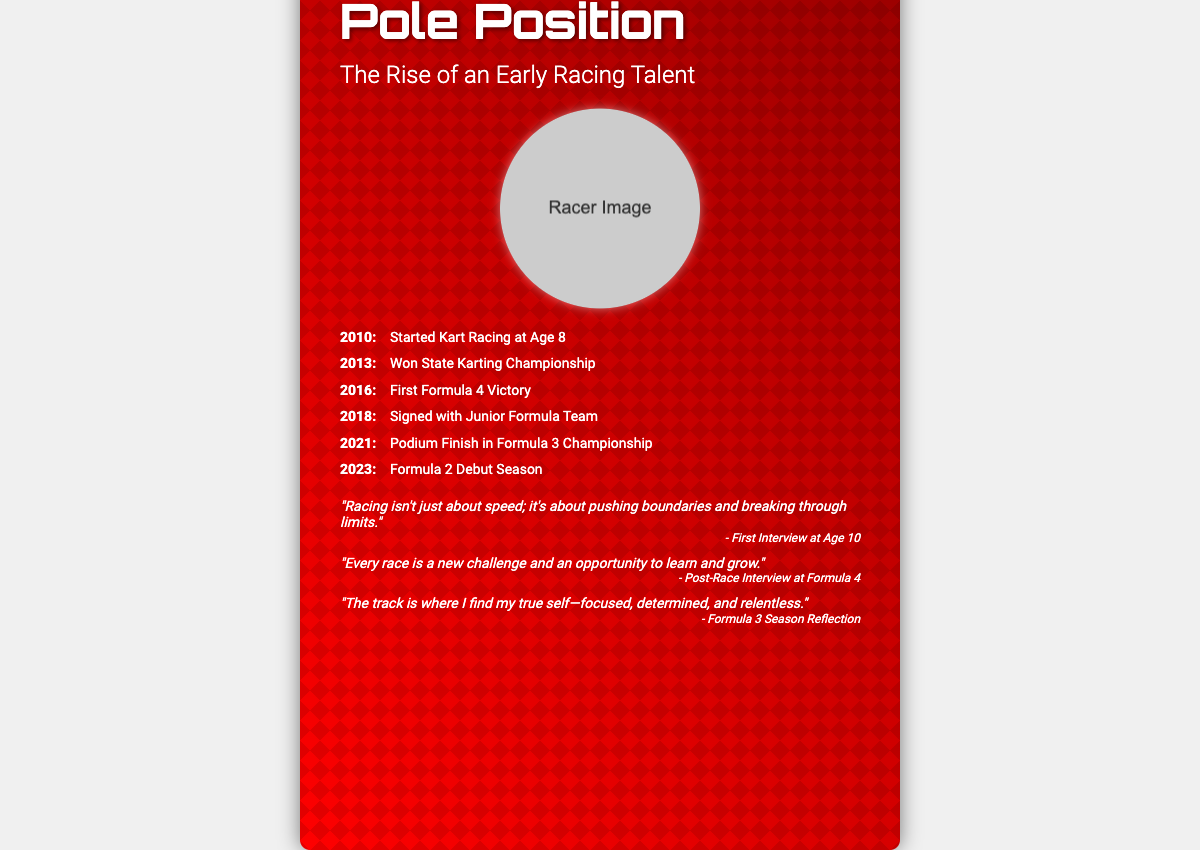What is the title of the book? The title of the book is prominently displayed at the top of the document.
Answer: Pole Position What year did the racer start kart racing? The document outlines key milestones in the racer's career, including the start of kart racing.
Answer: 2010 In which year did the racer win the state karting championship? The timeline shows the achievements in chronological order, specifically highlighting this victory.
Answer: 2013 What significant event happened in 2018? The timeline details milestones, including this particular signing event.
Answer: Signed with Junior Formula Team What quote reflects the racer's view on racing challenges? The document lists several personal quotes, one of which focuses on the concept of challenges.
Answer: "Every race is a new challenge and an opportunity to learn and grow." How many career milestones are listed in the timeline? The timeline contains a series of milestones which can be counted.
Answer: 6 What is the design motif in the background of the book cover? The document describes a background design that features a specific racing symbol.
Answer: Checkered flag What reflects the racer’s focus during races? The document includes quotes that express the racer's mindset while racing.
Answer: "The track is where I find my true self—focused, determined, and relentless." What type of racing did the racer debut in 2023? The timeline indicates the specific category of racing debuting for the racer.
Answer: Formula 2 